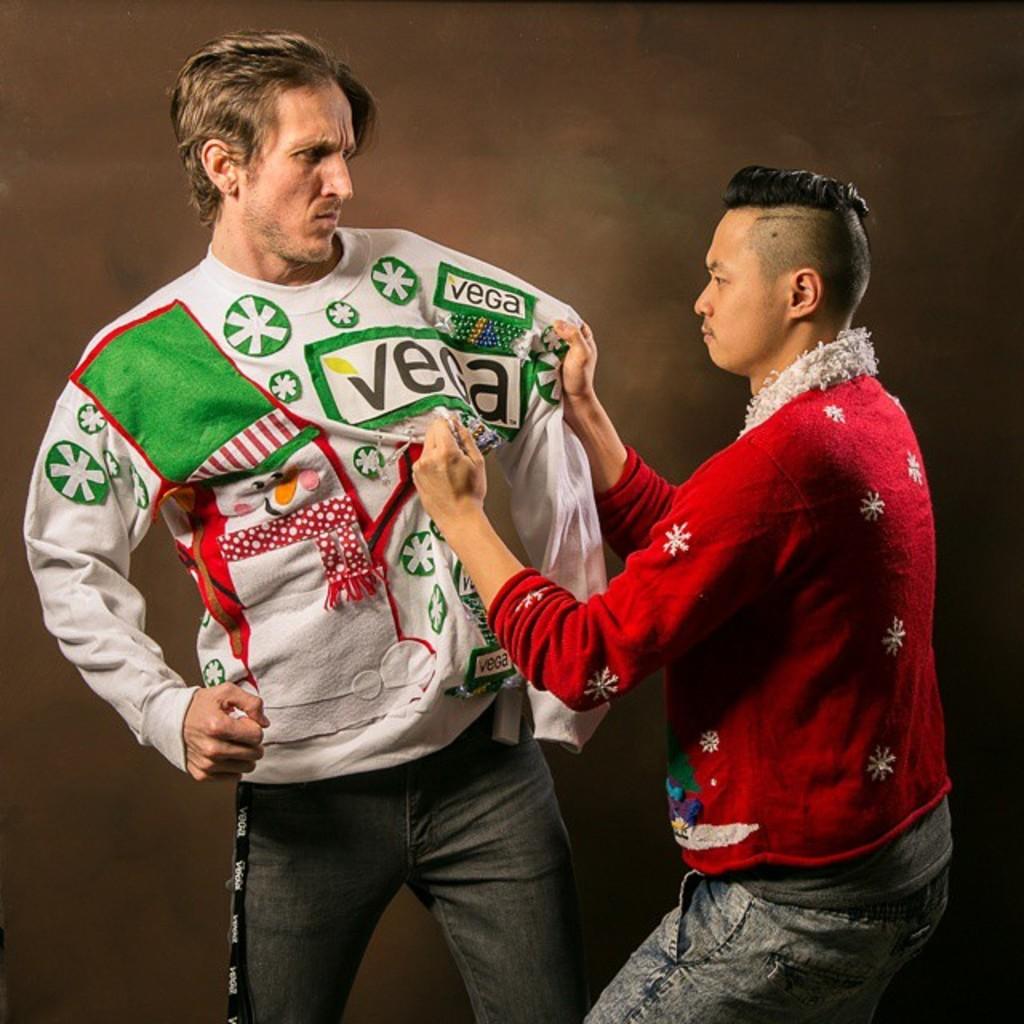What does the mans sweater say?
Your answer should be very brief. Vega. 